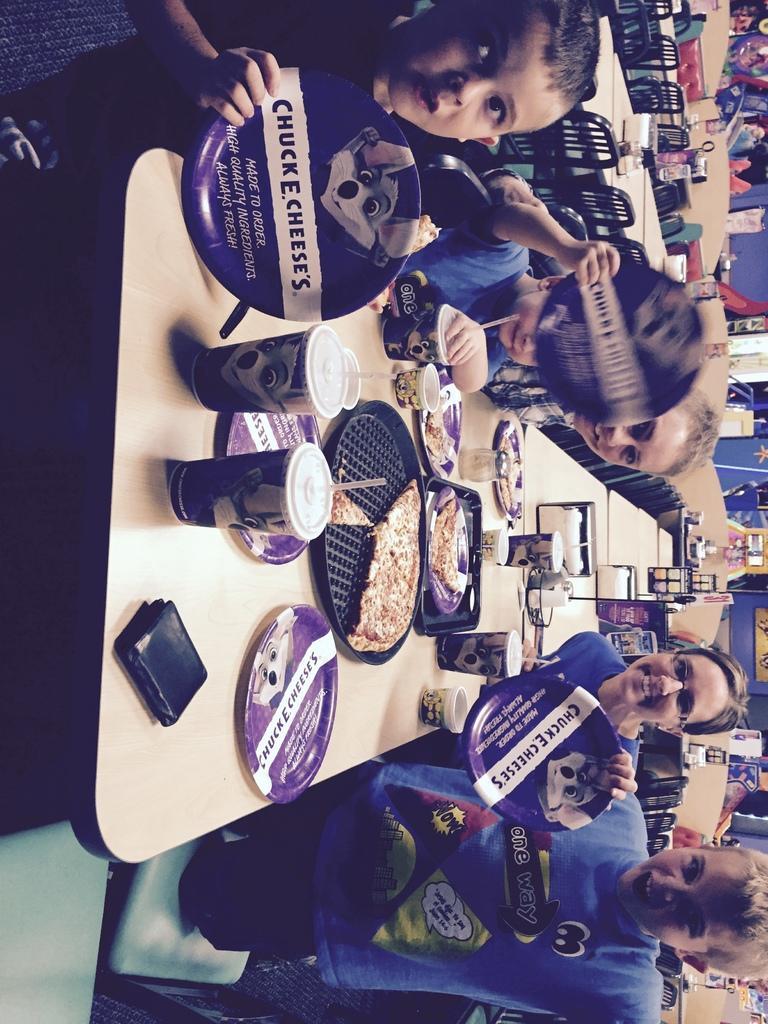Describe this image in one or two sentences. In the image I can see some people who are sitting around the table on which there are some glasses, plates and other things and also I can see some other chairs, tables and people. 